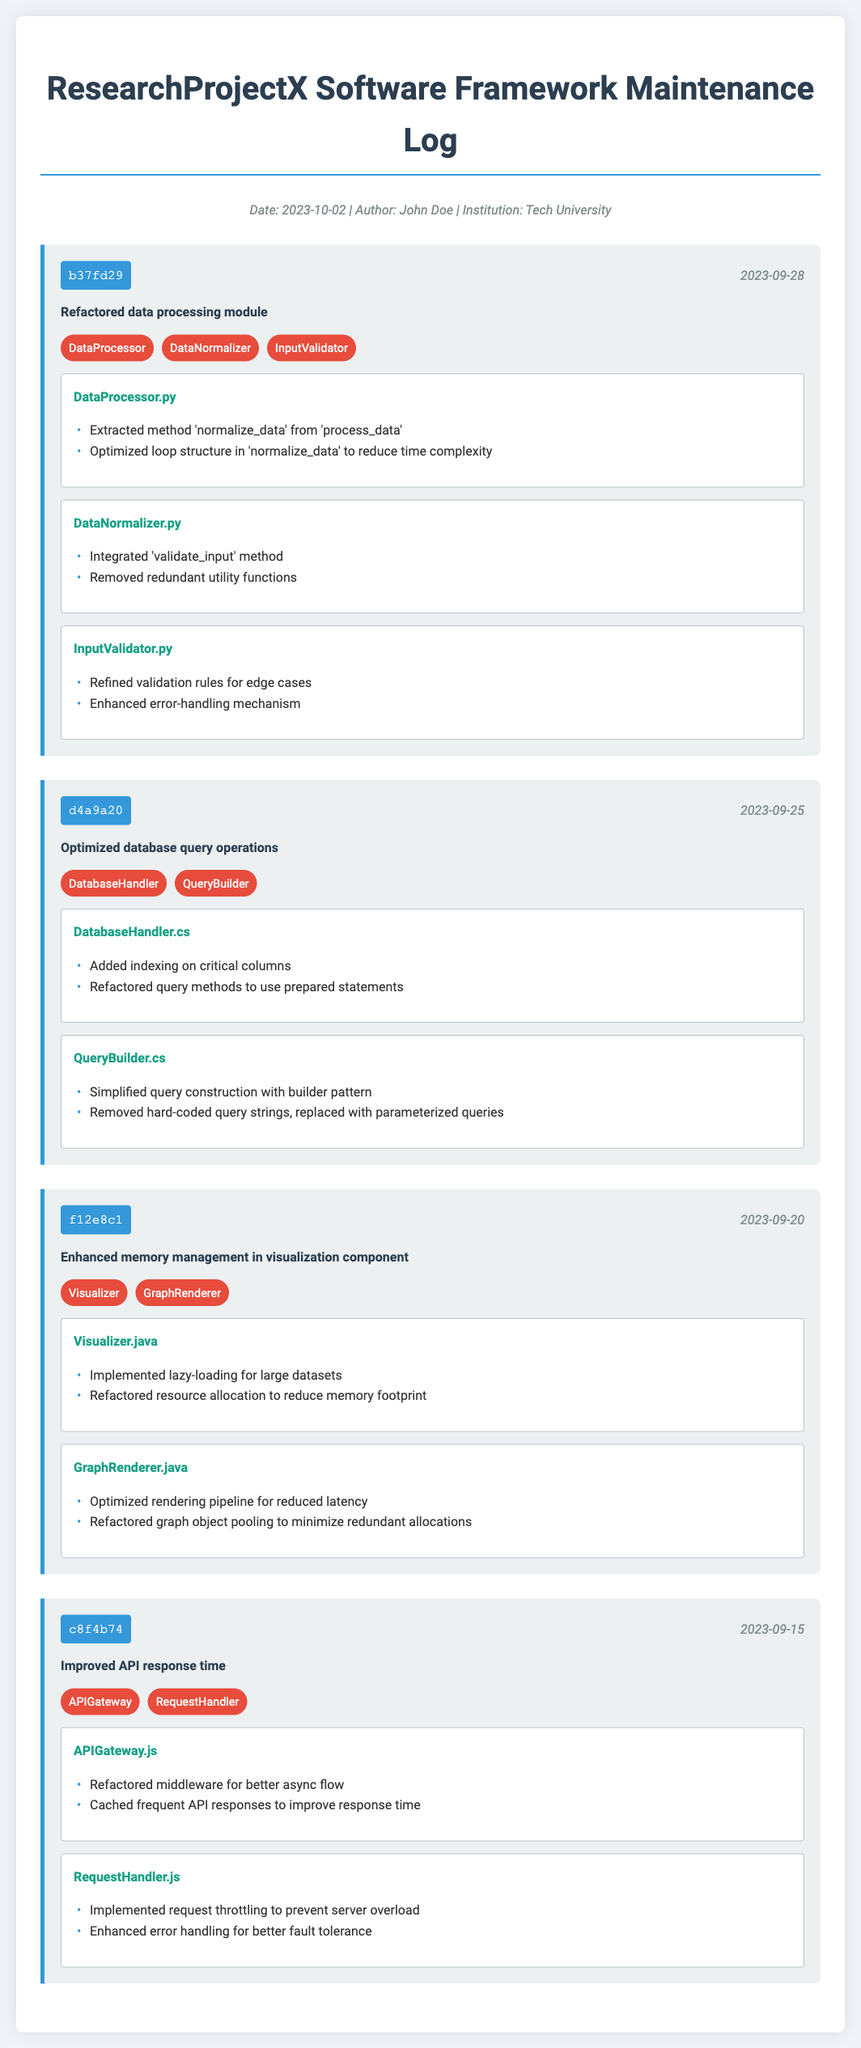What is the title of the document? The title is prominently displayed at the top of the document, which reads "ResearchProjectX Software Framework Maintenance Log."
Answer: ResearchProjectX Software Framework Maintenance Log Who is the author of the latest commit? The author name is included in the header information, specifically noted beside the date.
Answer: John Doe What date was the commit with ID "b37fd29" made? The commit date is provided in the commit header for the specific commit entry.
Answer: 2023-09-28 How many modules were affected in the commit that optimized database query operations? This number can be found in the corresponding commit entry under "modules affected."
Answer: 2 Which file has been enhanced for memory management? The file name is mentioned under the file changes section of the respective commit entry.
Answer: Visualizer.java What was one change made in the "GraphRenderer.java" file? The changes are detailed in the file changes section of the commit with respect to this file.
Answer: Optimized rendering pipeline for reduced latency Which optimization technique was used in the APIGateway.js file? The document specifies improvements that result from the changes made in that file.
Answer: Cached frequent API responses to improve response time What is the commit ID for the entry that focuses on memory management? The commit ID is clearly displayed at the beginning of each commit entry.
Answer: f12e8c1 